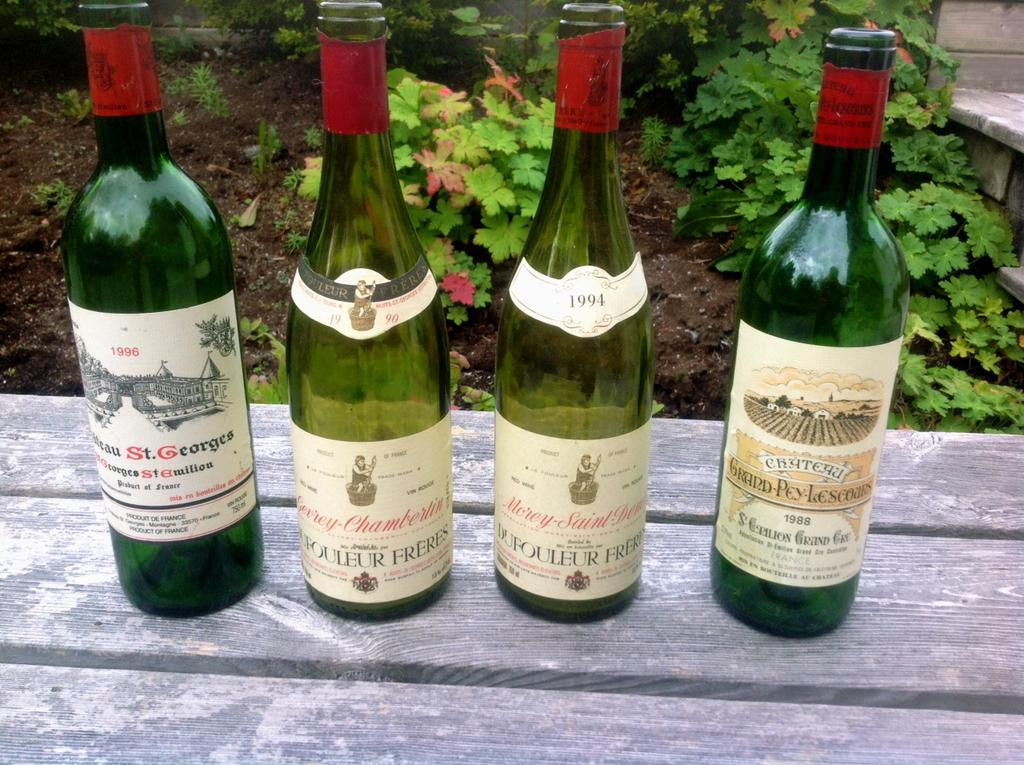Where was the image taken? The image is taken outdoors. What objects are on the bench in the image? There are four wine bottles on a bench in the image. What is the color of the wine bottles? The wine bottles are green in color. What can be seen behind the wine bottles? There are plants and soil visible behind the bottles. What type of window can be seen in the image? There is no window present in the image; it is taken outdoors. What is the engine used for in the image? There is no engine present in the image. 